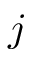Convert formula to latex. <formula><loc_0><loc_0><loc_500><loc_500>j</formula> 